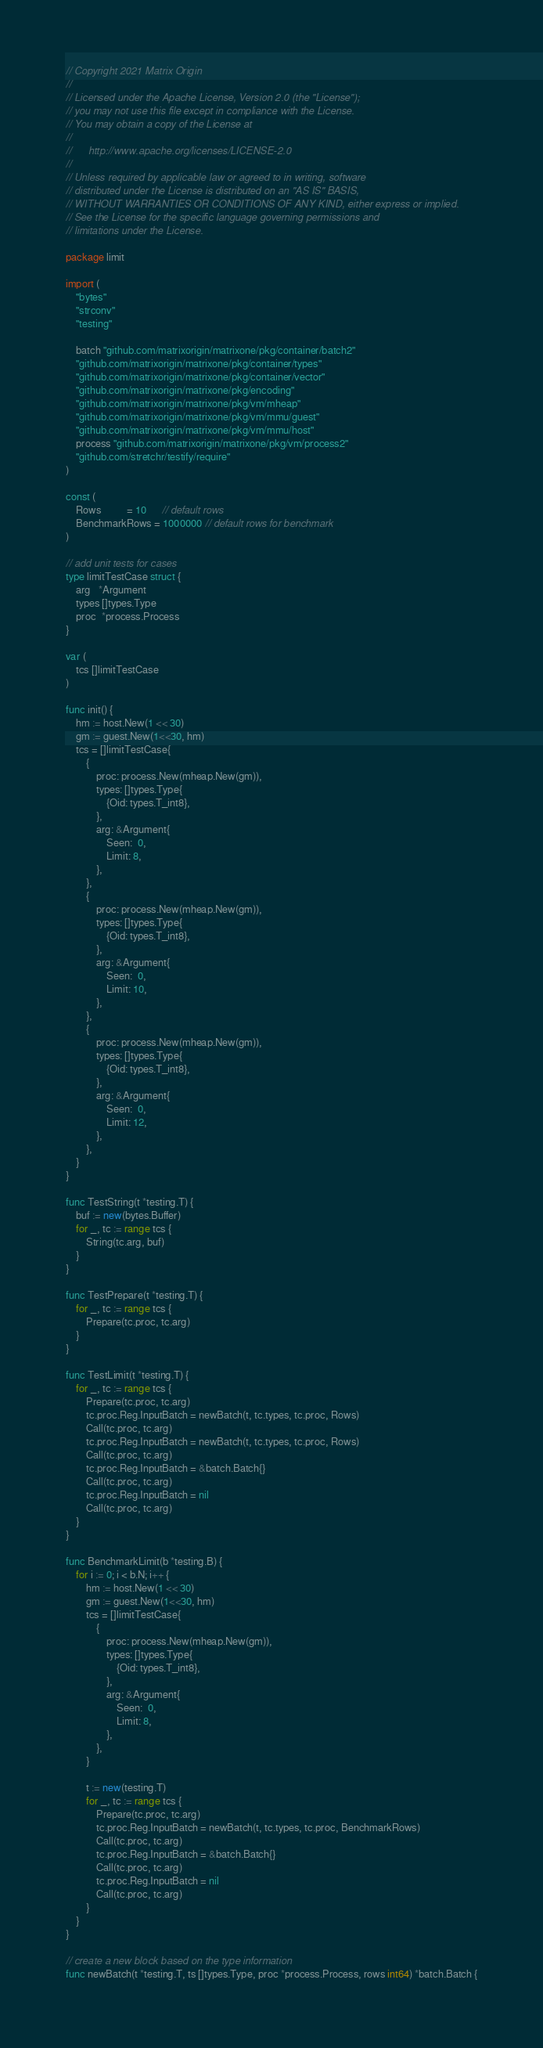Convert code to text. <code><loc_0><loc_0><loc_500><loc_500><_Go_>// Copyright 2021 Matrix Origin
//
// Licensed under the Apache License, Version 2.0 (the "License");
// you may not use this file except in compliance with the License.
// You may obtain a copy of the License at
//
//      http://www.apache.org/licenses/LICENSE-2.0
//
// Unless required by applicable law or agreed to in writing, software
// distributed under the License is distributed on an "AS IS" BASIS,
// WITHOUT WARRANTIES OR CONDITIONS OF ANY KIND, either express or implied.
// See the License for the specific language governing permissions and
// limitations under the License.

package limit

import (
	"bytes"
	"strconv"
	"testing"

	batch "github.com/matrixorigin/matrixone/pkg/container/batch2"
	"github.com/matrixorigin/matrixone/pkg/container/types"
	"github.com/matrixorigin/matrixone/pkg/container/vector"
	"github.com/matrixorigin/matrixone/pkg/encoding"
	"github.com/matrixorigin/matrixone/pkg/vm/mheap"
	"github.com/matrixorigin/matrixone/pkg/vm/mmu/guest"
	"github.com/matrixorigin/matrixone/pkg/vm/mmu/host"
	process "github.com/matrixorigin/matrixone/pkg/vm/process2"
	"github.com/stretchr/testify/require"
)

const (
	Rows          = 10      // default rows
	BenchmarkRows = 1000000 // default rows for benchmark
)

// add unit tests for cases
type limitTestCase struct {
	arg   *Argument
	types []types.Type
	proc  *process.Process
}

var (
	tcs []limitTestCase
)

func init() {
	hm := host.New(1 << 30)
	gm := guest.New(1<<30, hm)
	tcs = []limitTestCase{
		{
			proc: process.New(mheap.New(gm)),
			types: []types.Type{
				{Oid: types.T_int8},
			},
			arg: &Argument{
				Seen:  0,
				Limit: 8,
			},
		},
		{
			proc: process.New(mheap.New(gm)),
			types: []types.Type{
				{Oid: types.T_int8},
			},
			arg: &Argument{
				Seen:  0,
				Limit: 10,
			},
		},
		{
			proc: process.New(mheap.New(gm)),
			types: []types.Type{
				{Oid: types.T_int8},
			},
			arg: &Argument{
				Seen:  0,
				Limit: 12,
			},
		},
	}
}

func TestString(t *testing.T) {
	buf := new(bytes.Buffer)
	for _, tc := range tcs {
		String(tc.arg, buf)
	}
}

func TestPrepare(t *testing.T) {
	for _, tc := range tcs {
		Prepare(tc.proc, tc.arg)
	}
}

func TestLimit(t *testing.T) {
	for _, tc := range tcs {
		Prepare(tc.proc, tc.arg)
		tc.proc.Reg.InputBatch = newBatch(t, tc.types, tc.proc, Rows)
		Call(tc.proc, tc.arg)
		tc.proc.Reg.InputBatch = newBatch(t, tc.types, tc.proc, Rows)
		Call(tc.proc, tc.arg)
		tc.proc.Reg.InputBatch = &batch.Batch{}
		Call(tc.proc, tc.arg)
		tc.proc.Reg.InputBatch = nil
		Call(tc.proc, tc.arg)
	}
}

func BenchmarkLimit(b *testing.B) {
	for i := 0; i < b.N; i++ {
		hm := host.New(1 << 30)
		gm := guest.New(1<<30, hm)
		tcs = []limitTestCase{
			{
				proc: process.New(mheap.New(gm)),
				types: []types.Type{
					{Oid: types.T_int8},
				},
				arg: &Argument{
					Seen:  0,
					Limit: 8,
				},
			},
		}

		t := new(testing.T)
		for _, tc := range tcs {
			Prepare(tc.proc, tc.arg)
			tc.proc.Reg.InputBatch = newBatch(t, tc.types, tc.proc, BenchmarkRows)
			Call(tc.proc, tc.arg)
			tc.proc.Reg.InputBatch = &batch.Batch{}
			Call(tc.proc, tc.arg)
			tc.proc.Reg.InputBatch = nil
			Call(tc.proc, tc.arg)
		}
	}
}

// create a new block based on the type information
func newBatch(t *testing.T, ts []types.Type, proc *process.Process, rows int64) *batch.Batch {</code> 